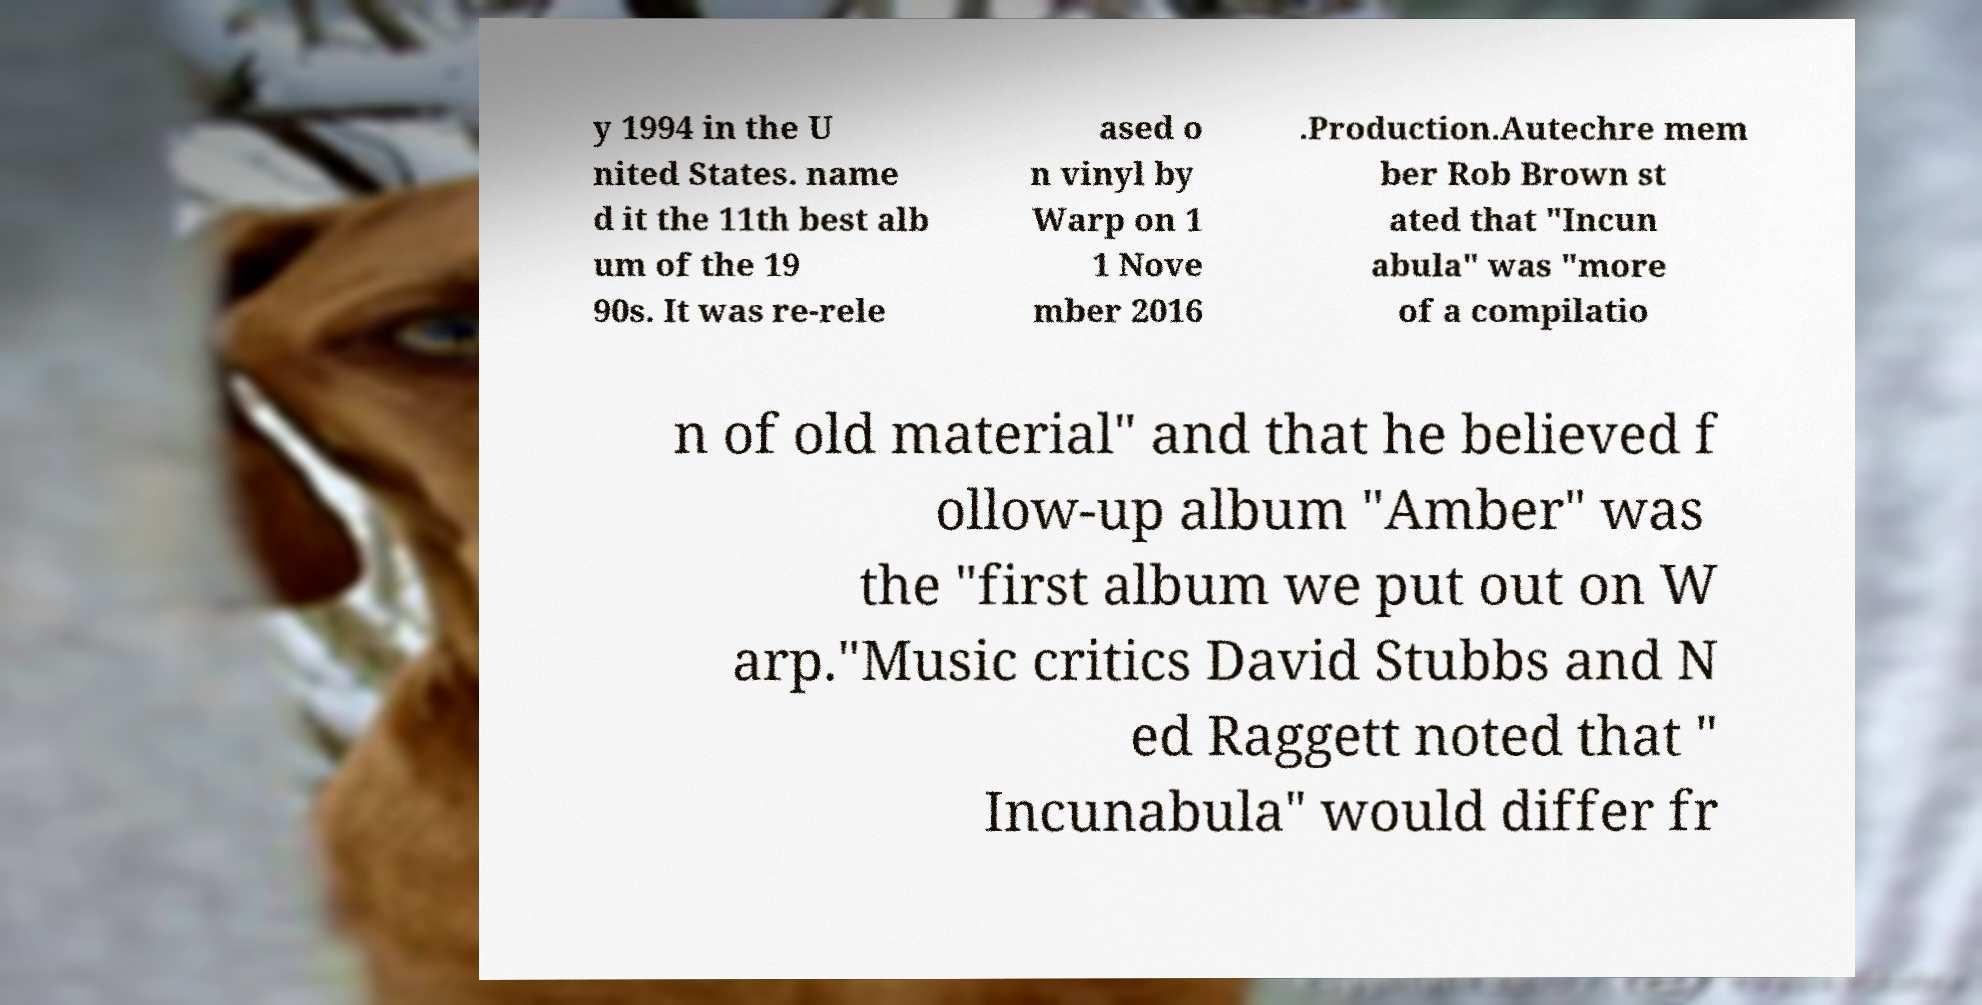I need the written content from this picture converted into text. Can you do that? y 1994 in the U nited States. name d it the 11th best alb um of the 19 90s. It was re-rele ased o n vinyl by Warp on 1 1 Nove mber 2016 .Production.Autechre mem ber Rob Brown st ated that "Incun abula" was "more of a compilatio n of old material" and that he believed f ollow-up album "Amber" was the "first album we put out on W arp."Music critics David Stubbs and N ed Raggett noted that " Incunabula" would differ fr 